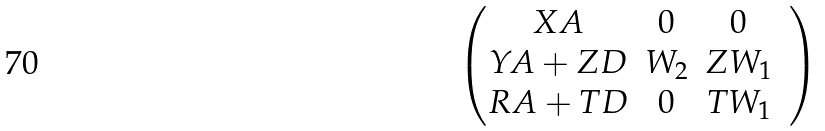<formula> <loc_0><loc_0><loc_500><loc_500>\begin{pmatrix} X A & 0 & 0 & \\ Y A + Z D & W _ { 2 } & Z W _ { 1 } & \\ R A + T D & 0 & T W _ { 1 } & \\ \end{pmatrix}</formula> 